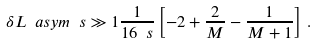Convert formula to latex. <formula><loc_0><loc_0><loc_500><loc_500>\delta L \ a s y m { \ s \gg 1 } \frac { 1 } { 1 6 \ s } \left [ - 2 + \frac { 2 } { M } - \frac { 1 } { M + 1 } \right ] \, .</formula> 